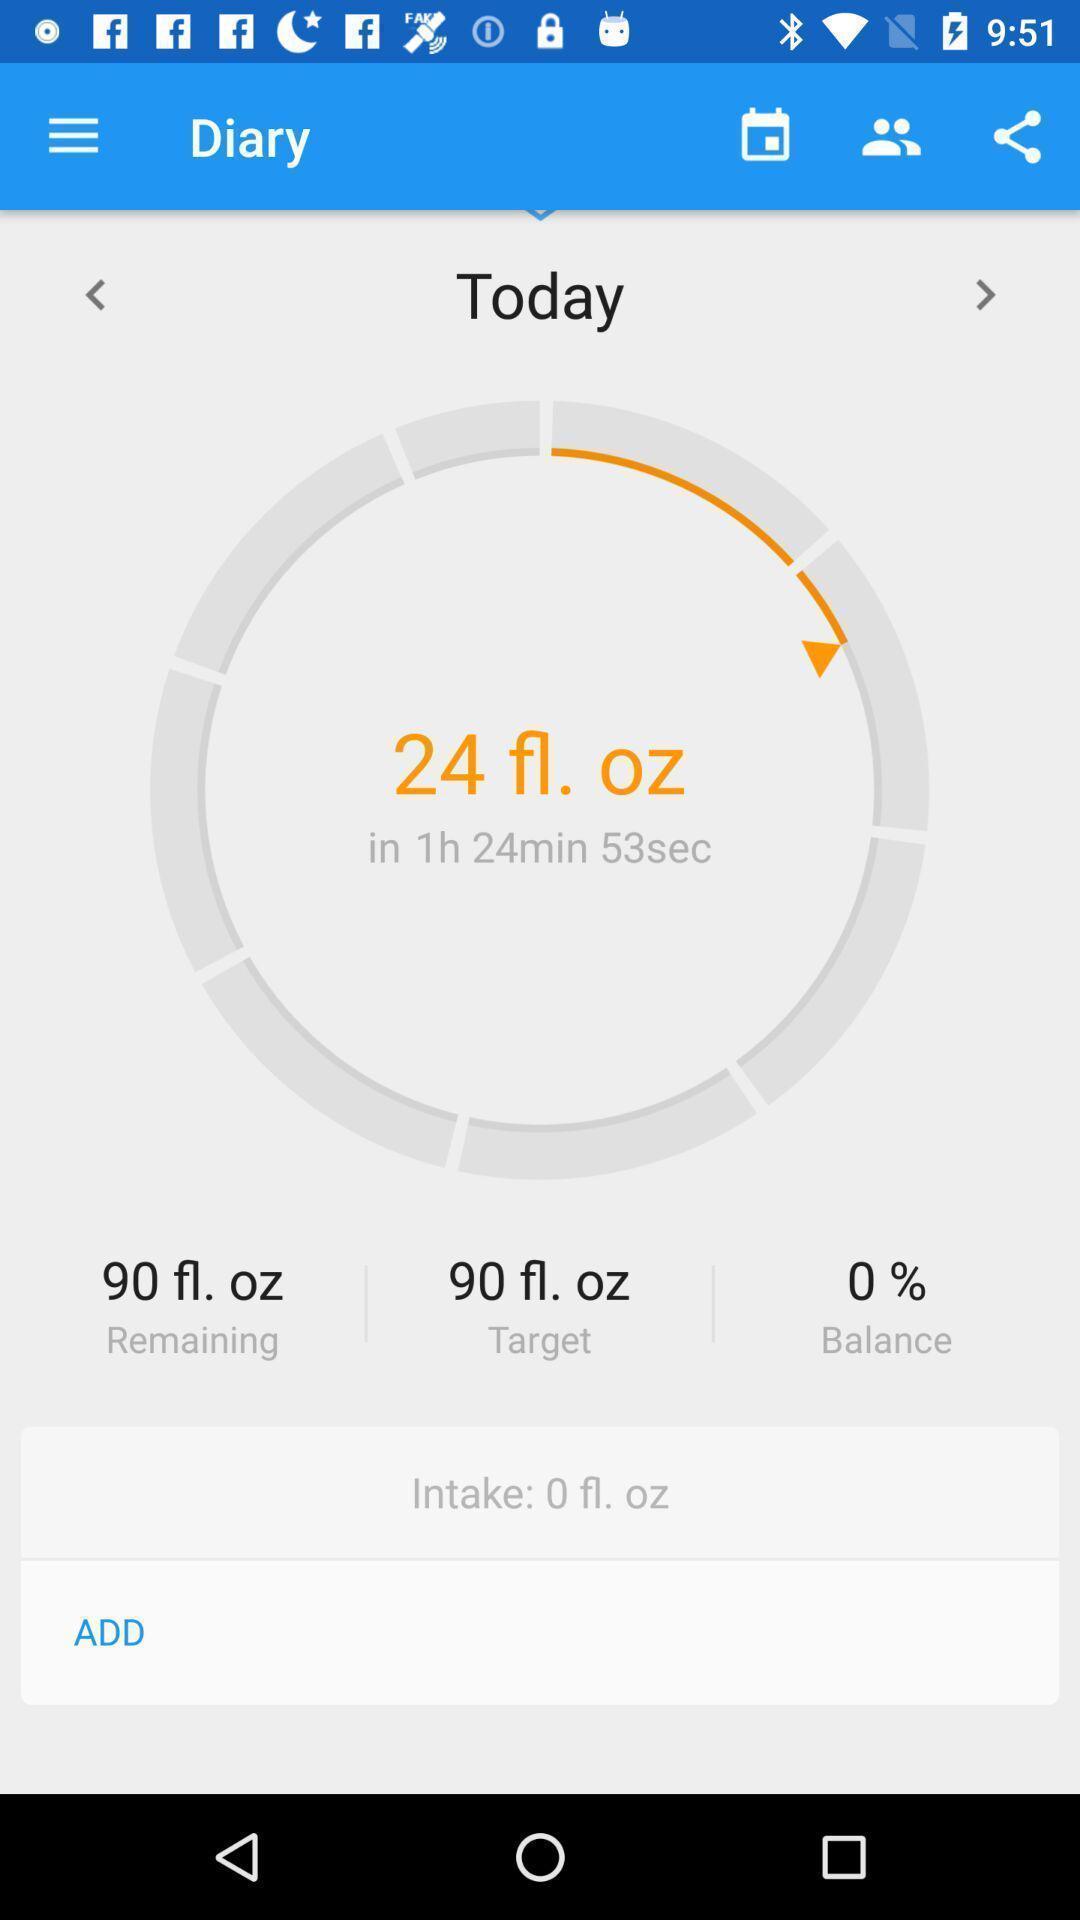Give me a narrative description of this picture. Page displaying option to add. 